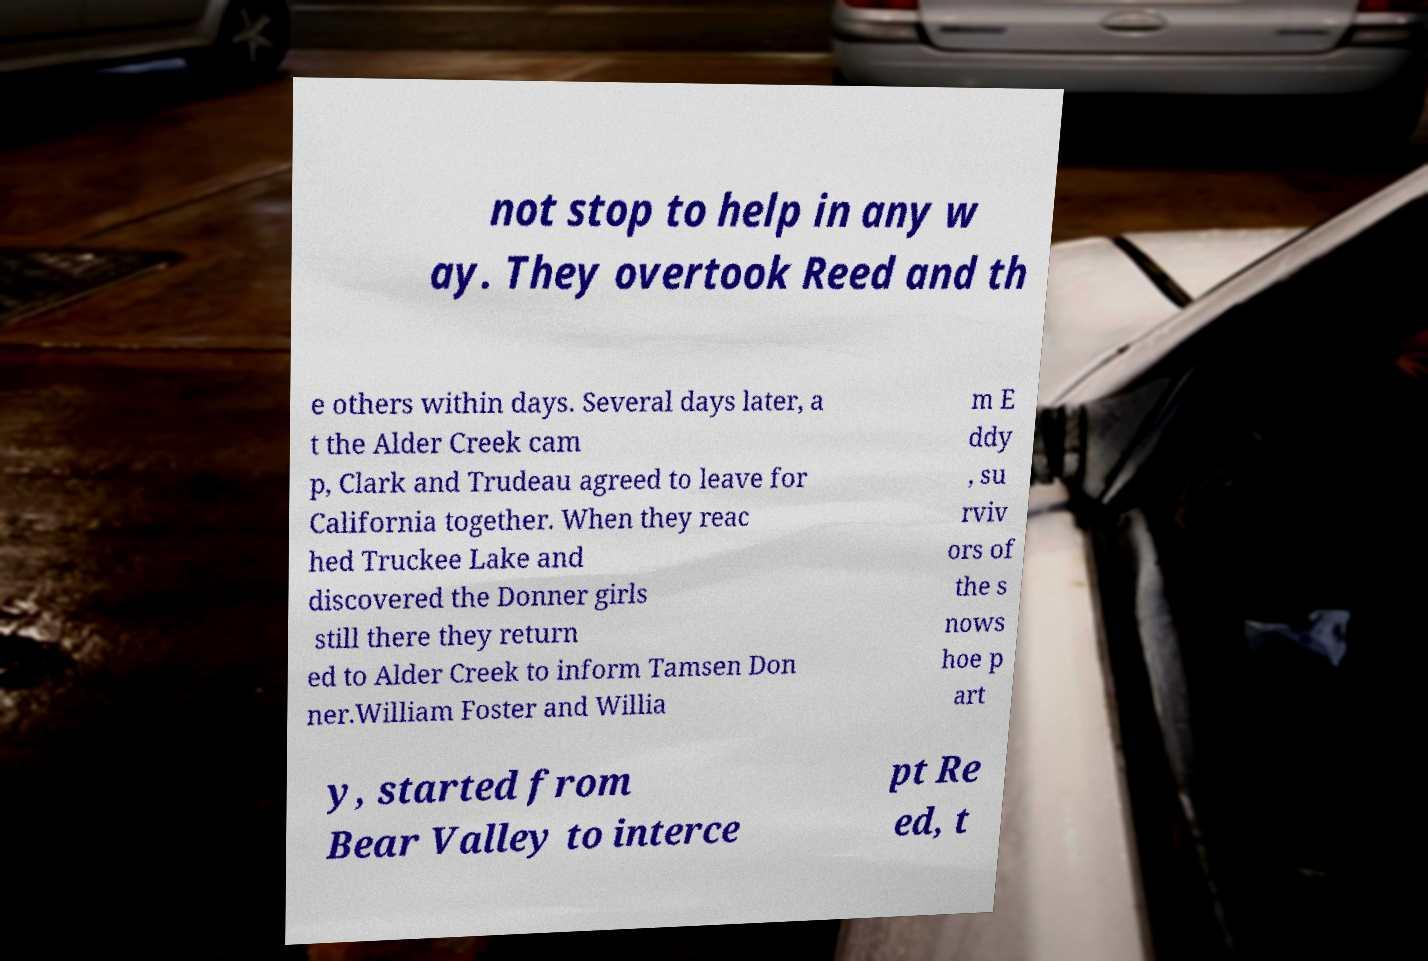Could you extract and type out the text from this image? not stop to help in any w ay. They overtook Reed and th e others within days. Several days later, a t the Alder Creek cam p, Clark and Trudeau agreed to leave for California together. When they reac hed Truckee Lake and discovered the Donner girls still there they return ed to Alder Creek to inform Tamsen Don ner.William Foster and Willia m E ddy , su rviv ors of the s nows hoe p art y, started from Bear Valley to interce pt Re ed, t 